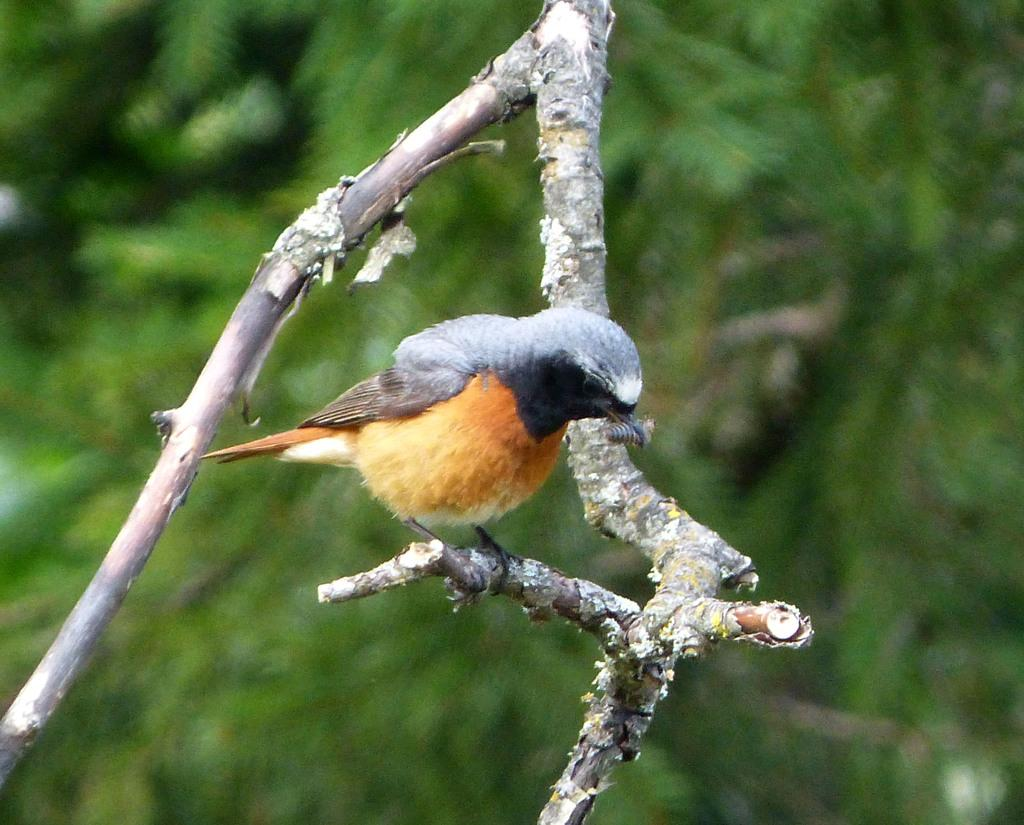What type of animal is in the image? There is a bird in the image. What colors can be seen on the bird? The bird is yellow and black in color. Where is the bird located in the image? The bird is on a tree branch. Can you describe the background of the image? The background of the image is blurred. What type of lift is present in the image? There is no lift present in the image; it features a bird on a tree branch. How does the bird's brain affect the image? The bird's brain is not visible in the image, and its function cannot be determined from the image. 